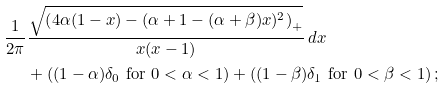<formula> <loc_0><loc_0><loc_500><loc_500>\frac { 1 } { 2 \pi } & \frac { \sqrt { \left ( 4 \alpha ( 1 - x ) - ( \alpha + 1 - ( \alpha + \beta ) x ) ^ { 2 } \right ) _ { + } } } { x ( x - 1 ) } \, d x \\ & + \left ( ( 1 - \alpha ) \delta _ { 0 } \text { for } 0 < \alpha < 1 \right ) + \left ( ( 1 - \beta ) \delta _ { 1 } \text { for } 0 < \beta < 1 \right ) ;</formula> 